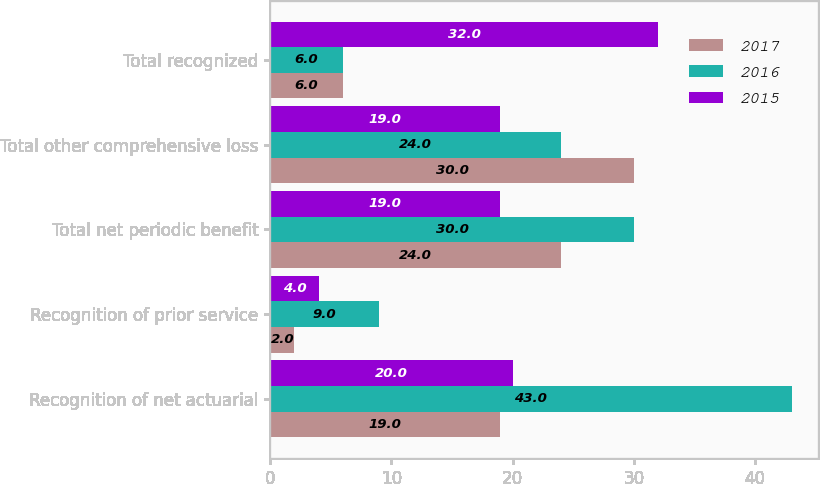Convert chart to OTSL. <chart><loc_0><loc_0><loc_500><loc_500><stacked_bar_chart><ecel><fcel>Recognition of net actuarial<fcel>Recognition of prior service<fcel>Total net periodic benefit<fcel>Total other comprehensive loss<fcel>Total recognized<nl><fcel>2017<fcel>19<fcel>2<fcel>24<fcel>30<fcel>6<nl><fcel>2016<fcel>43<fcel>9<fcel>30<fcel>24<fcel>6<nl><fcel>2015<fcel>20<fcel>4<fcel>19<fcel>19<fcel>32<nl></chart> 